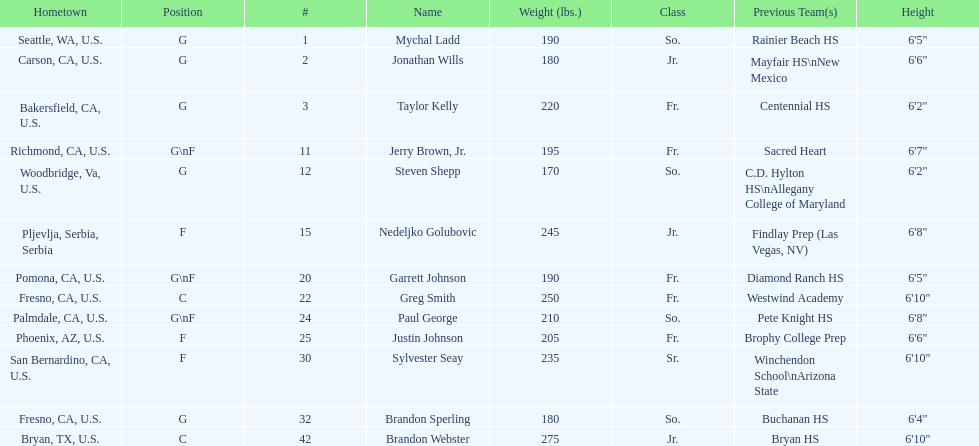What is the number of players who weight over 200 pounds? 7. 